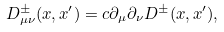<formula> <loc_0><loc_0><loc_500><loc_500>D _ { \mu \nu } ^ { \pm } ( x , x ^ { \prime } ) = c \partial _ { \mu } \partial _ { \nu } D ^ { \pm } ( x , x ^ { \prime } ) ,</formula> 